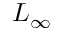<formula> <loc_0><loc_0><loc_500><loc_500>L _ { \infty }</formula> 